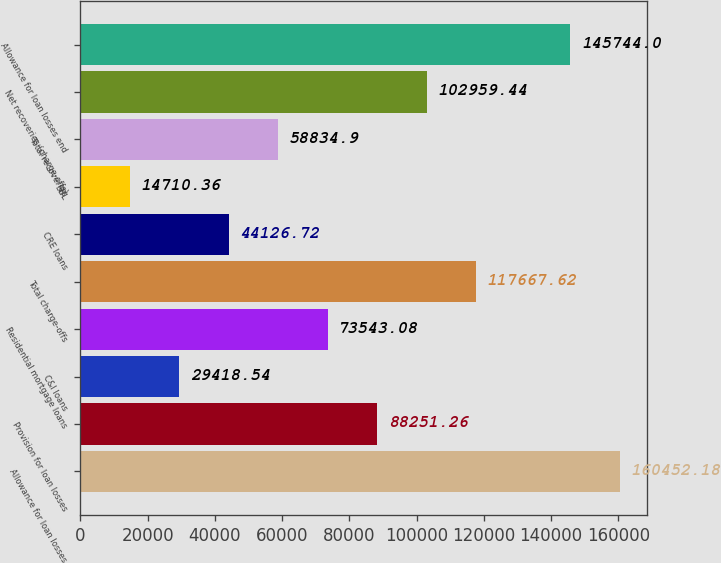<chart> <loc_0><loc_0><loc_500><loc_500><bar_chart><fcel>Allowance for loan losses<fcel>Provision for loan losses<fcel>C&I loans<fcel>Residential mortgage loans<fcel>Total charge-offs<fcel>CRE loans<fcel>SBL<fcel>Total recoveries<fcel>Net recoveries (charge-offs)<fcel>Allowance for loan losses end<nl><fcel>160452<fcel>88251.3<fcel>29418.5<fcel>73543.1<fcel>117668<fcel>44126.7<fcel>14710.4<fcel>58834.9<fcel>102959<fcel>145744<nl></chart> 